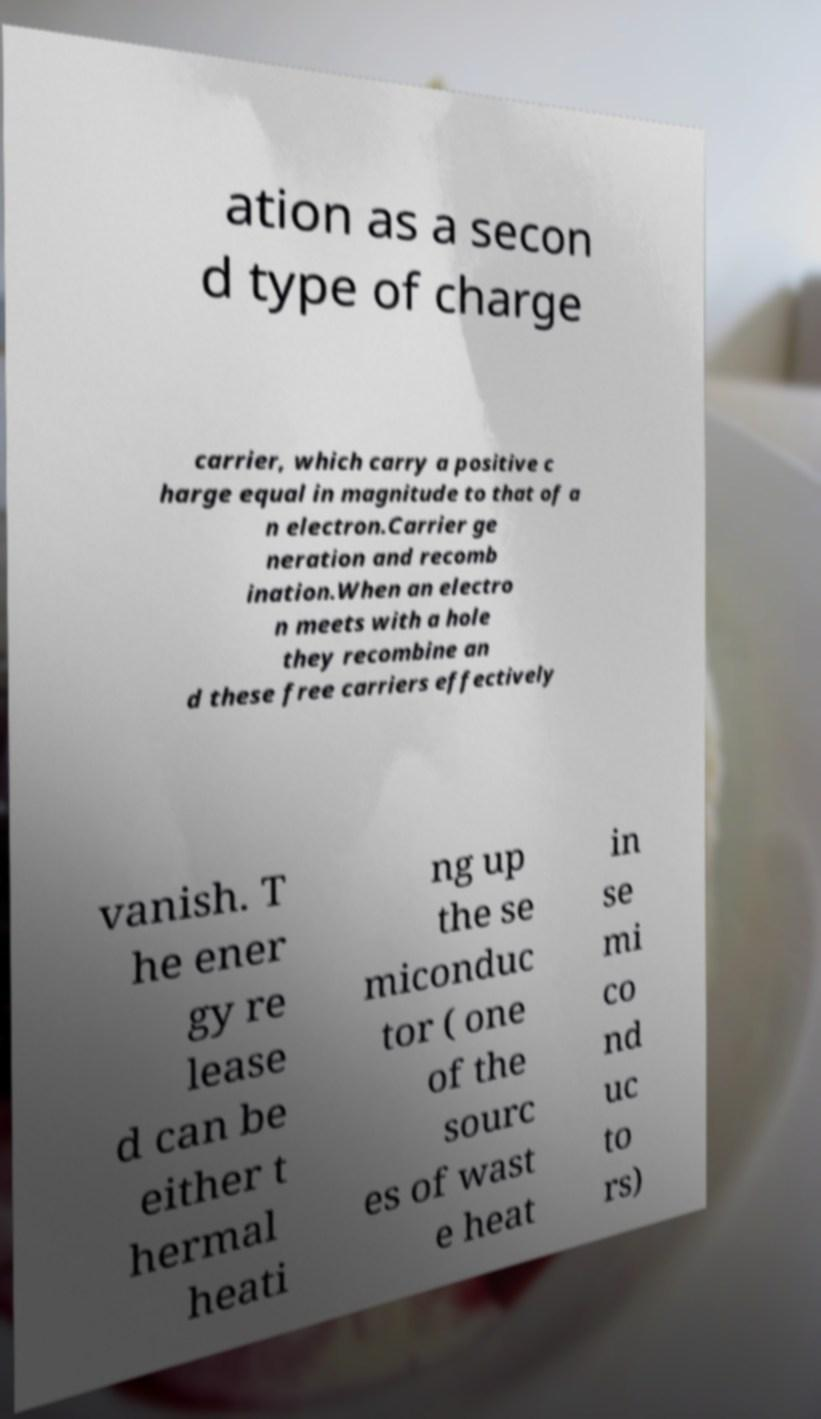What messages or text are displayed in this image? I need them in a readable, typed format. ation as a secon d type of charge carrier, which carry a positive c harge equal in magnitude to that of a n electron.Carrier ge neration and recomb ination.When an electro n meets with a hole they recombine an d these free carriers effectively vanish. T he ener gy re lease d can be either t hermal heati ng up the se miconduc tor ( one of the sourc es of wast e heat in se mi co nd uc to rs) 